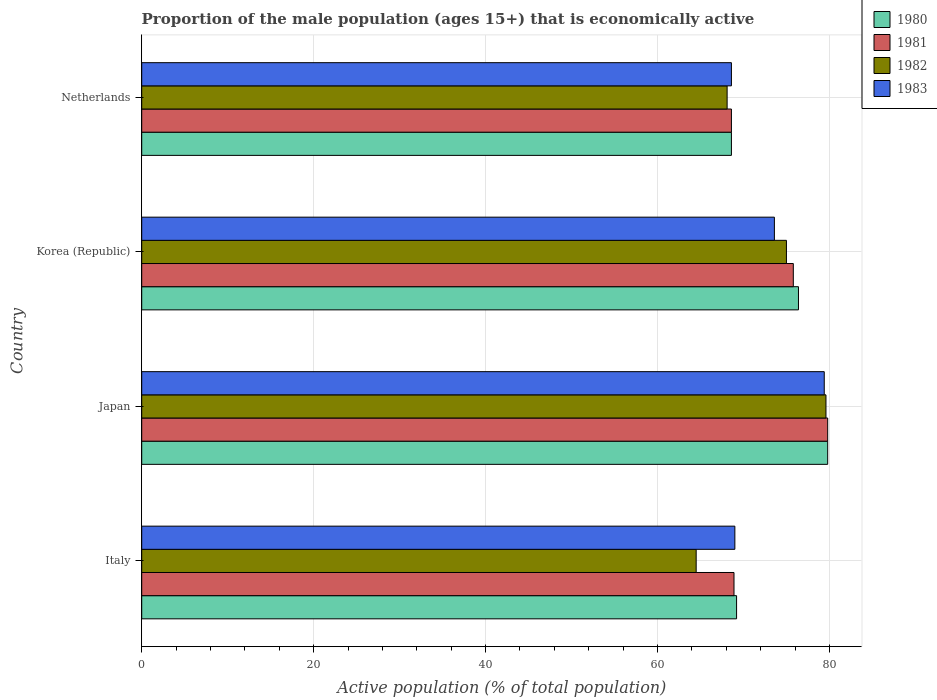How many different coloured bars are there?
Provide a short and direct response. 4. Are the number of bars per tick equal to the number of legend labels?
Provide a succinct answer. Yes. Are the number of bars on each tick of the Y-axis equal?
Give a very brief answer. Yes. How many bars are there on the 4th tick from the bottom?
Your answer should be very brief. 4. What is the proportion of the male population that is economically active in 1980 in Korea (Republic)?
Your response must be concise. 76.4. Across all countries, what is the maximum proportion of the male population that is economically active in 1982?
Provide a short and direct response. 79.6. Across all countries, what is the minimum proportion of the male population that is economically active in 1981?
Ensure brevity in your answer.  68.6. In which country was the proportion of the male population that is economically active in 1983 maximum?
Give a very brief answer. Japan. In which country was the proportion of the male population that is economically active in 1980 minimum?
Provide a succinct answer. Netherlands. What is the total proportion of the male population that is economically active in 1982 in the graph?
Your answer should be compact. 287.2. What is the difference between the proportion of the male population that is economically active in 1980 in Japan and that in Netherlands?
Provide a short and direct response. 11.2. What is the difference between the proportion of the male population that is economically active in 1980 in Korea (Republic) and the proportion of the male population that is economically active in 1981 in Netherlands?
Give a very brief answer. 7.8. What is the average proportion of the male population that is economically active in 1981 per country?
Provide a succinct answer. 73.28. What is the difference between the proportion of the male population that is economically active in 1981 and proportion of the male population that is economically active in 1982 in Italy?
Your response must be concise. 4.4. What is the ratio of the proportion of the male population that is economically active in 1982 in Korea (Republic) to that in Netherlands?
Offer a very short reply. 1.1. What is the difference between the highest and the second highest proportion of the male population that is economically active in 1980?
Keep it short and to the point. 3.4. What is the difference between the highest and the lowest proportion of the male population that is economically active in 1982?
Your answer should be compact. 15.1. In how many countries, is the proportion of the male population that is economically active in 1982 greater than the average proportion of the male population that is economically active in 1982 taken over all countries?
Offer a terse response. 2. What does the 4th bar from the top in Japan represents?
Give a very brief answer. 1980. What does the 2nd bar from the bottom in Korea (Republic) represents?
Provide a succinct answer. 1981. Is it the case that in every country, the sum of the proportion of the male population that is economically active in 1981 and proportion of the male population that is economically active in 1980 is greater than the proportion of the male population that is economically active in 1982?
Your answer should be very brief. Yes. How many bars are there?
Give a very brief answer. 16. Are all the bars in the graph horizontal?
Your answer should be compact. Yes. What is the difference between two consecutive major ticks on the X-axis?
Give a very brief answer. 20. Are the values on the major ticks of X-axis written in scientific E-notation?
Give a very brief answer. No. Does the graph contain any zero values?
Provide a short and direct response. No. Does the graph contain grids?
Offer a very short reply. Yes. How are the legend labels stacked?
Your answer should be compact. Vertical. What is the title of the graph?
Keep it short and to the point. Proportion of the male population (ages 15+) that is economically active. What is the label or title of the X-axis?
Your answer should be very brief. Active population (% of total population). What is the Active population (% of total population) of 1980 in Italy?
Provide a short and direct response. 69.2. What is the Active population (% of total population) of 1981 in Italy?
Your answer should be very brief. 68.9. What is the Active population (% of total population) in 1982 in Italy?
Provide a short and direct response. 64.5. What is the Active population (% of total population) in 1980 in Japan?
Your response must be concise. 79.8. What is the Active population (% of total population) of 1981 in Japan?
Provide a succinct answer. 79.8. What is the Active population (% of total population) in 1982 in Japan?
Give a very brief answer. 79.6. What is the Active population (% of total population) in 1983 in Japan?
Offer a very short reply. 79.4. What is the Active population (% of total population) in 1980 in Korea (Republic)?
Your answer should be very brief. 76.4. What is the Active population (% of total population) of 1981 in Korea (Republic)?
Your response must be concise. 75.8. What is the Active population (% of total population) in 1983 in Korea (Republic)?
Give a very brief answer. 73.6. What is the Active population (% of total population) in 1980 in Netherlands?
Offer a very short reply. 68.6. What is the Active population (% of total population) in 1981 in Netherlands?
Offer a terse response. 68.6. What is the Active population (% of total population) of 1982 in Netherlands?
Make the answer very short. 68.1. What is the Active population (% of total population) in 1983 in Netherlands?
Provide a succinct answer. 68.6. Across all countries, what is the maximum Active population (% of total population) of 1980?
Your answer should be very brief. 79.8. Across all countries, what is the maximum Active population (% of total population) of 1981?
Offer a very short reply. 79.8. Across all countries, what is the maximum Active population (% of total population) of 1982?
Make the answer very short. 79.6. Across all countries, what is the maximum Active population (% of total population) in 1983?
Provide a succinct answer. 79.4. Across all countries, what is the minimum Active population (% of total population) in 1980?
Provide a succinct answer. 68.6. Across all countries, what is the minimum Active population (% of total population) in 1981?
Give a very brief answer. 68.6. Across all countries, what is the minimum Active population (% of total population) in 1982?
Offer a terse response. 64.5. Across all countries, what is the minimum Active population (% of total population) in 1983?
Ensure brevity in your answer.  68.6. What is the total Active population (% of total population) in 1980 in the graph?
Your answer should be compact. 294. What is the total Active population (% of total population) in 1981 in the graph?
Make the answer very short. 293.1. What is the total Active population (% of total population) in 1982 in the graph?
Provide a short and direct response. 287.2. What is the total Active population (% of total population) in 1983 in the graph?
Give a very brief answer. 290.6. What is the difference between the Active population (% of total population) in 1981 in Italy and that in Japan?
Offer a terse response. -10.9. What is the difference between the Active population (% of total population) in 1982 in Italy and that in Japan?
Your answer should be very brief. -15.1. What is the difference between the Active population (% of total population) of 1983 in Italy and that in Japan?
Keep it short and to the point. -10.4. What is the difference between the Active population (% of total population) in 1980 in Italy and that in Korea (Republic)?
Ensure brevity in your answer.  -7.2. What is the difference between the Active population (% of total population) in 1981 in Italy and that in Korea (Republic)?
Offer a very short reply. -6.9. What is the difference between the Active population (% of total population) of 1982 in Italy and that in Korea (Republic)?
Offer a terse response. -10.5. What is the difference between the Active population (% of total population) in 1981 in Italy and that in Netherlands?
Offer a very short reply. 0.3. What is the difference between the Active population (% of total population) in 1982 in Italy and that in Netherlands?
Keep it short and to the point. -3.6. What is the difference between the Active population (% of total population) in 1983 in Italy and that in Netherlands?
Offer a very short reply. 0.4. What is the difference between the Active population (% of total population) of 1982 in Japan and that in Korea (Republic)?
Your response must be concise. 4.6. What is the difference between the Active population (% of total population) of 1980 in Japan and that in Netherlands?
Your answer should be compact. 11.2. What is the difference between the Active population (% of total population) of 1981 in Japan and that in Netherlands?
Your answer should be very brief. 11.2. What is the difference between the Active population (% of total population) in 1982 in Japan and that in Netherlands?
Your answer should be very brief. 11.5. What is the difference between the Active population (% of total population) of 1982 in Korea (Republic) and that in Netherlands?
Your response must be concise. 6.9. What is the difference between the Active population (% of total population) in 1980 in Italy and the Active population (% of total population) in 1981 in Japan?
Your answer should be very brief. -10.6. What is the difference between the Active population (% of total population) in 1980 in Italy and the Active population (% of total population) in 1982 in Japan?
Give a very brief answer. -10.4. What is the difference between the Active population (% of total population) in 1980 in Italy and the Active population (% of total population) in 1983 in Japan?
Give a very brief answer. -10.2. What is the difference between the Active population (% of total population) of 1982 in Italy and the Active population (% of total population) of 1983 in Japan?
Provide a succinct answer. -14.9. What is the difference between the Active population (% of total population) of 1980 in Italy and the Active population (% of total population) of 1981 in Korea (Republic)?
Make the answer very short. -6.6. What is the difference between the Active population (% of total population) in 1980 in Italy and the Active population (% of total population) in 1981 in Netherlands?
Provide a succinct answer. 0.6. What is the difference between the Active population (% of total population) of 1980 in Italy and the Active population (% of total population) of 1983 in Netherlands?
Offer a terse response. 0.6. What is the difference between the Active population (% of total population) of 1981 in Italy and the Active population (% of total population) of 1982 in Netherlands?
Provide a short and direct response. 0.8. What is the difference between the Active population (% of total population) of 1980 in Japan and the Active population (% of total population) of 1983 in Korea (Republic)?
Offer a very short reply. 6.2. What is the difference between the Active population (% of total population) in 1981 in Japan and the Active population (% of total population) in 1982 in Korea (Republic)?
Make the answer very short. 4.8. What is the difference between the Active population (% of total population) of 1982 in Japan and the Active population (% of total population) of 1983 in Korea (Republic)?
Make the answer very short. 6. What is the difference between the Active population (% of total population) in 1981 in Japan and the Active population (% of total population) in 1983 in Netherlands?
Offer a very short reply. 11.2. What is the difference between the Active population (% of total population) in 1980 in Korea (Republic) and the Active population (% of total population) in 1981 in Netherlands?
Give a very brief answer. 7.8. What is the difference between the Active population (% of total population) of 1980 in Korea (Republic) and the Active population (% of total population) of 1982 in Netherlands?
Your answer should be compact. 8.3. What is the difference between the Active population (% of total population) of 1982 in Korea (Republic) and the Active population (% of total population) of 1983 in Netherlands?
Offer a very short reply. 6.4. What is the average Active population (% of total population) in 1980 per country?
Give a very brief answer. 73.5. What is the average Active population (% of total population) of 1981 per country?
Give a very brief answer. 73.28. What is the average Active population (% of total population) in 1982 per country?
Provide a succinct answer. 71.8. What is the average Active population (% of total population) of 1983 per country?
Give a very brief answer. 72.65. What is the difference between the Active population (% of total population) in 1981 and Active population (% of total population) in 1983 in Italy?
Your response must be concise. -0.1. What is the difference between the Active population (% of total population) in 1982 and Active population (% of total population) in 1983 in Italy?
Your response must be concise. -4.5. What is the difference between the Active population (% of total population) of 1980 and Active population (% of total population) of 1982 in Japan?
Offer a very short reply. 0.2. What is the difference between the Active population (% of total population) in 1980 and Active population (% of total population) in 1983 in Japan?
Your answer should be very brief. 0.4. What is the difference between the Active population (% of total population) of 1981 and Active population (% of total population) of 1982 in Japan?
Provide a short and direct response. 0.2. What is the difference between the Active population (% of total population) of 1981 and Active population (% of total population) of 1983 in Japan?
Offer a very short reply. 0.4. What is the difference between the Active population (% of total population) of 1982 and Active population (% of total population) of 1983 in Japan?
Your answer should be very brief. 0.2. What is the difference between the Active population (% of total population) of 1980 and Active population (% of total population) of 1981 in Korea (Republic)?
Keep it short and to the point. 0.6. What is the difference between the Active population (% of total population) in 1980 and Active population (% of total population) in 1983 in Korea (Republic)?
Give a very brief answer. 2.8. What is the difference between the Active population (% of total population) in 1980 and Active population (% of total population) in 1981 in Netherlands?
Keep it short and to the point. 0. What is the difference between the Active population (% of total population) of 1982 and Active population (% of total population) of 1983 in Netherlands?
Provide a succinct answer. -0.5. What is the ratio of the Active population (% of total population) of 1980 in Italy to that in Japan?
Provide a short and direct response. 0.87. What is the ratio of the Active population (% of total population) of 1981 in Italy to that in Japan?
Make the answer very short. 0.86. What is the ratio of the Active population (% of total population) in 1982 in Italy to that in Japan?
Your answer should be compact. 0.81. What is the ratio of the Active population (% of total population) in 1983 in Italy to that in Japan?
Provide a short and direct response. 0.87. What is the ratio of the Active population (% of total population) of 1980 in Italy to that in Korea (Republic)?
Ensure brevity in your answer.  0.91. What is the ratio of the Active population (% of total population) of 1981 in Italy to that in Korea (Republic)?
Your answer should be compact. 0.91. What is the ratio of the Active population (% of total population) in 1982 in Italy to that in Korea (Republic)?
Make the answer very short. 0.86. What is the ratio of the Active population (% of total population) in 1980 in Italy to that in Netherlands?
Provide a short and direct response. 1.01. What is the ratio of the Active population (% of total population) of 1981 in Italy to that in Netherlands?
Your response must be concise. 1. What is the ratio of the Active population (% of total population) in 1982 in Italy to that in Netherlands?
Your answer should be very brief. 0.95. What is the ratio of the Active population (% of total population) of 1983 in Italy to that in Netherlands?
Provide a short and direct response. 1.01. What is the ratio of the Active population (% of total population) in 1980 in Japan to that in Korea (Republic)?
Make the answer very short. 1.04. What is the ratio of the Active population (% of total population) in 1981 in Japan to that in Korea (Republic)?
Your answer should be very brief. 1.05. What is the ratio of the Active population (% of total population) of 1982 in Japan to that in Korea (Republic)?
Make the answer very short. 1.06. What is the ratio of the Active population (% of total population) of 1983 in Japan to that in Korea (Republic)?
Give a very brief answer. 1.08. What is the ratio of the Active population (% of total population) in 1980 in Japan to that in Netherlands?
Your answer should be very brief. 1.16. What is the ratio of the Active population (% of total population) of 1981 in Japan to that in Netherlands?
Your response must be concise. 1.16. What is the ratio of the Active population (% of total population) in 1982 in Japan to that in Netherlands?
Ensure brevity in your answer.  1.17. What is the ratio of the Active population (% of total population) of 1983 in Japan to that in Netherlands?
Ensure brevity in your answer.  1.16. What is the ratio of the Active population (% of total population) of 1980 in Korea (Republic) to that in Netherlands?
Ensure brevity in your answer.  1.11. What is the ratio of the Active population (% of total population) in 1981 in Korea (Republic) to that in Netherlands?
Ensure brevity in your answer.  1.1. What is the ratio of the Active population (% of total population) of 1982 in Korea (Republic) to that in Netherlands?
Provide a succinct answer. 1.1. What is the ratio of the Active population (% of total population) of 1983 in Korea (Republic) to that in Netherlands?
Provide a succinct answer. 1.07. What is the difference between the highest and the second highest Active population (% of total population) in 1981?
Provide a succinct answer. 4. What is the difference between the highest and the second highest Active population (% of total population) of 1982?
Provide a succinct answer. 4.6. What is the difference between the highest and the lowest Active population (% of total population) of 1980?
Provide a succinct answer. 11.2. What is the difference between the highest and the lowest Active population (% of total population) of 1981?
Your answer should be very brief. 11.2. What is the difference between the highest and the lowest Active population (% of total population) of 1982?
Offer a terse response. 15.1. 